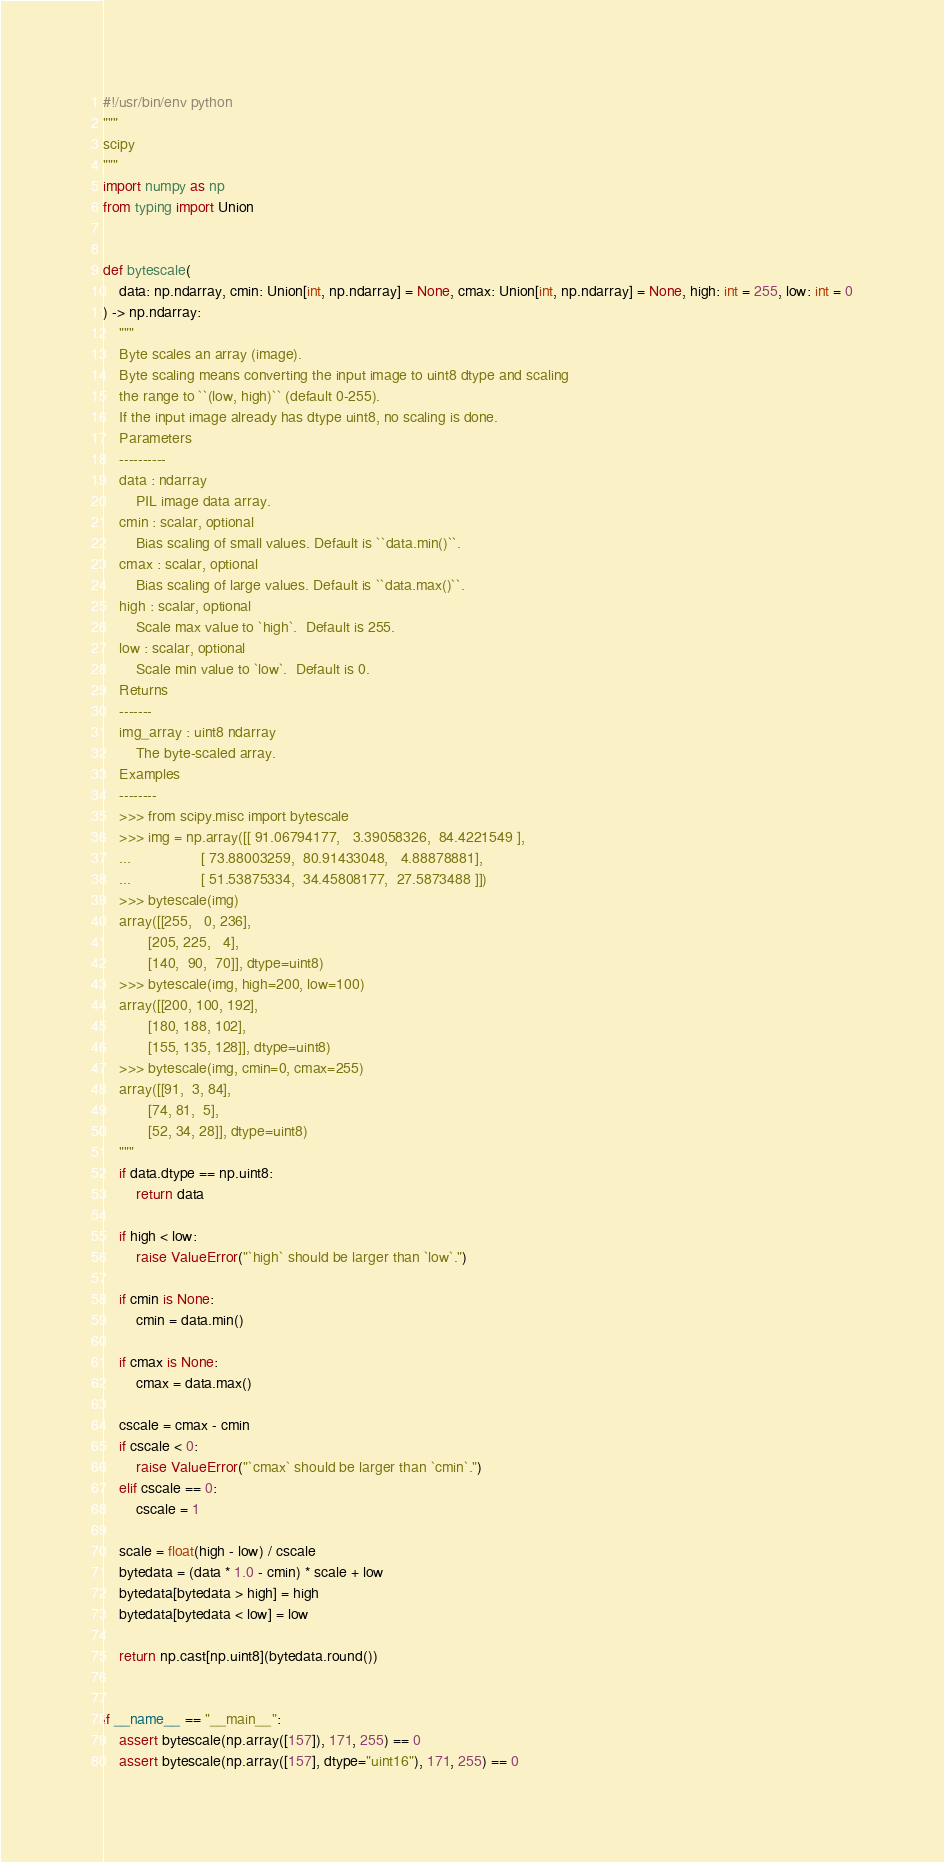Convert code to text. <code><loc_0><loc_0><loc_500><loc_500><_Python_>#!/usr/bin/env python
"""
scipy
"""
import numpy as np
from typing import Union


def bytescale(
    data: np.ndarray, cmin: Union[int, np.ndarray] = None, cmax: Union[int, np.ndarray] = None, high: int = 255, low: int = 0
) -> np.ndarray:
    """
    Byte scales an array (image).
    Byte scaling means converting the input image to uint8 dtype and scaling
    the range to ``(low, high)`` (default 0-255).
    If the input image already has dtype uint8, no scaling is done.
    Parameters
    ----------
    data : ndarray
        PIL image data array.
    cmin : scalar, optional
        Bias scaling of small values. Default is ``data.min()``.
    cmax : scalar, optional
        Bias scaling of large values. Default is ``data.max()``.
    high : scalar, optional
        Scale max value to `high`.  Default is 255.
    low : scalar, optional
        Scale min value to `low`.  Default is 0.
    Returns
    -------
    img_array : uint8 ndarray
        The byte-scaled array.
    Examples
    --------
    >>> from scipy.misc import bytescale
    >>> img = np.array([[ 91.06794177,   3.39058326,  84.4221549 ],
    ...                 [ 73.88003259,  80.91433048,   4.88878881],
    ...                 [ 51.53875334,  34.45808177,  27.5873488 ]])
    >>> bytescale(img)
    array([[255,   0, 236],
           [205, 225,   4],
           [140,  90,  70]], dtype=uint8)
    >>> bytescale(img, high=200, low=100)
    array([[200, 100, 192],
           [180, 188, 102],
           [155, 135, 128]], dtype=uint8)
    >>> bytescale(img, cmin=0, cmax=255)
    array([[91,  3, 84],
           [74, 81,  5],
           [52, 34, 28]], dtype=uint8)
    """
    if data.dtype == np.uint8:
        return data

    if high < low:
        raise ValueError("`high` should be larger than `low`.")

    if cmin is None:
        cmin = data.min()

    if cmax is None:
        cmax = data.max()

    cscale = cmax - cmin
    if cscale < 0:
        raise ValueError("`cmax` should be larger than `cmin`.")
    elif cscale == 0:
        cscale = 1

    scale = float(high - low) / cscale
    bytedata = (data * 1.0 - cmin) * scale + low
    bytedata[bytedata > high] = high
    bytedata[bytedata < low] = low

    return np.cast[np.uint8](bytedata.round())


if __name__ == "__main__":
    assert bytescale(np.array([157]), 171, 255) == 0
    assert bytescale(np.array([157], dtype="uint16"), 171, 255) == 0
</code> 